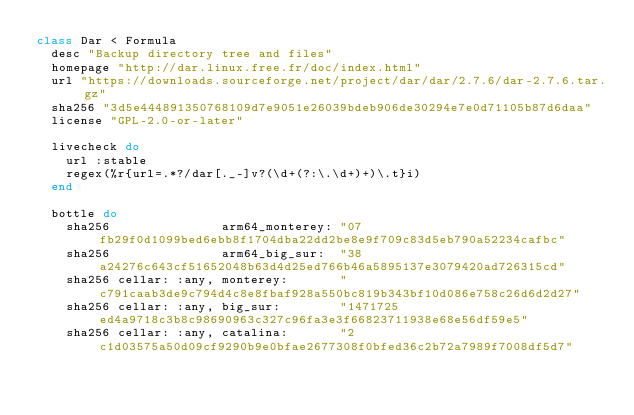<code> <loc_0><loc_0><loc_500><loc_500><_Ruby_>class Dar < Formula
  desc "Backup directory tree and files"
  homepage "http://dar.linux.free.fr/doc/index.html"
  url "https://downloads.sourceforge.net/project/dar/dar/2.7.6/dar-2.7.6.tar.gz"
  sha256 "3d5e444891350768109d7e9051e26039bdeb906de30294e7e0d71105b87d6daa"
  license "GPL-2.0-or-later"

  livecheck do
    url :stable
    regex(%r{url=.*?/dar[._-]v?(\d+(?:\.\d+)+)\.t}i)
  end

  bottle do
    sha256               arm64_monterey: "07fb29f0d1099bed6ebb8f1704dba22dd2be8e9f709c83d5eb790a52234cafbc"
    sha256               arm64_big_sur:  "38a24276c643cf51652048b63d4d25ed766b46a5895137e3079420ad726315cd"
    sha256 cellar: :any, monterey:       "c791caab3de9c794d4c8e8fbaf928a550bc819b343bf10d086e758c26d6d2d27"
    sha256 cellar: :any, big_sur:        "1471725ed4a9718c3b8c98690963c327c96fa3e3f66823711938e68e56df59e5"
    sha256 cellar: :any, catalina:       "2c1d03575a50d09cf9290b9e0bfae2677308f0bfed36c2b72a7989f7008df5d7"</code> 